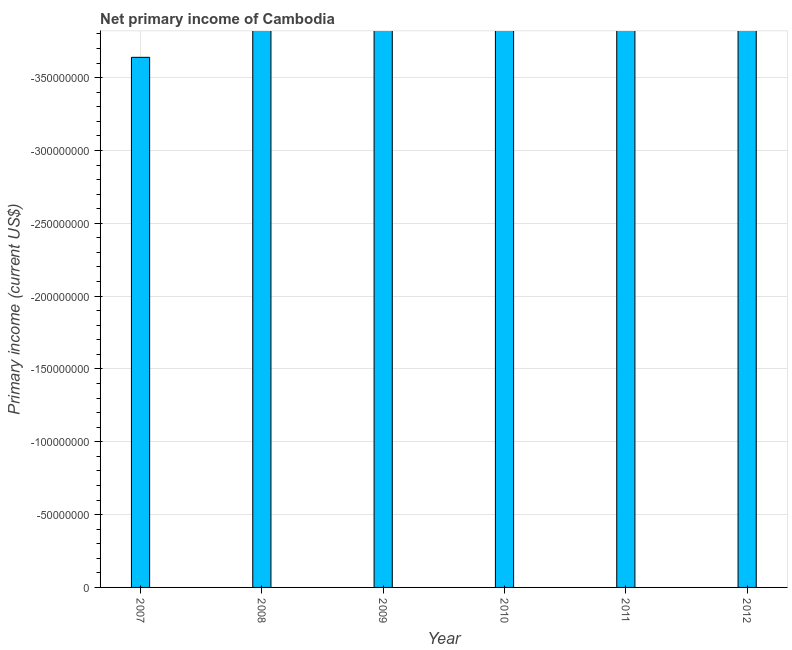Does the graph contain grids?
Ensure brevity in your answer.  Yes. What is the title of the graph?
Your answer should be very brief. Net primary income of Cambodia. What is the label or title of the Y-axis?
Your answer should be compact. Primary income (current US$). What is the median amount of primary income?
Provide a short and direct response. 0. How many bars are there?
Give a very brief answer. 0. What is the difference between two consecutive major ticks on the Y-axis?
Keep it short and to the point. 5.00e+07. Are the values on the major ticks of Y-axis written in scientific E-notation?
Offer a very short reply. No. What is the Primary income (current US$) in 2007?
Your answer should be compact. 0. What is the Primary income (current US$) in 2008?
Give a very brief answer. 0. 